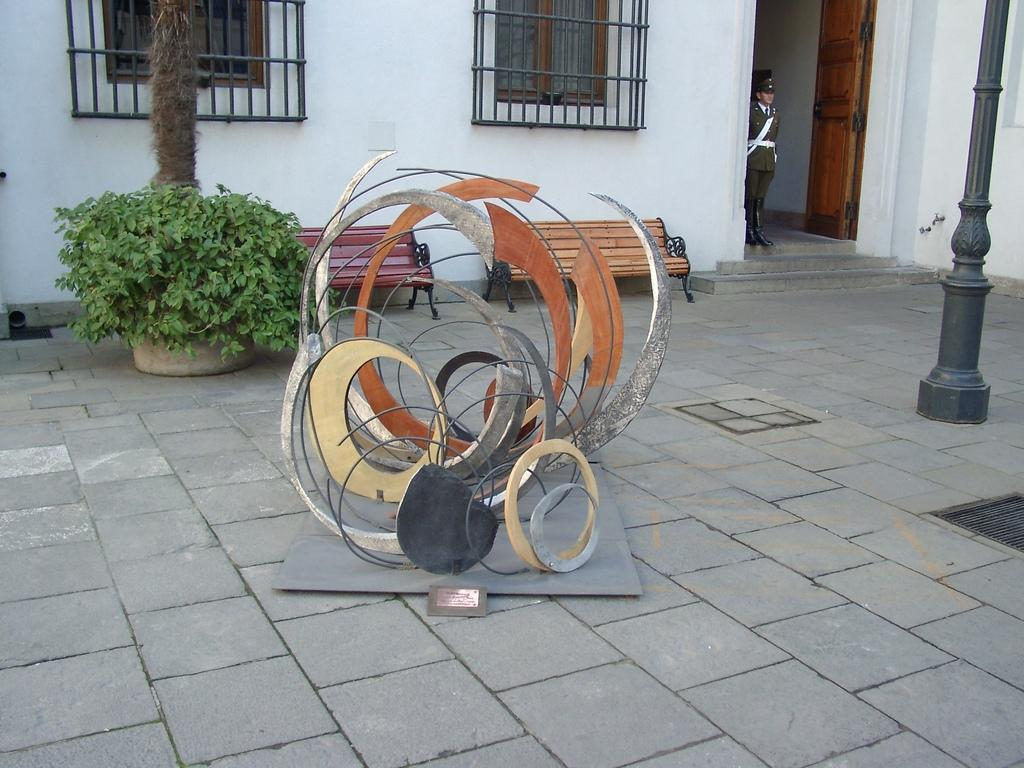What is the main object on the board in the image? The fact does not specify the type of object on the board, so we cannot answer this question definitively. What can be seen in the image besides the object on the board? There is a person standing, a pole, a plant, a building with windows and a door, benches, and iron grills in the image. Can you describe the person standing in the image? The fact does not provide any details about the person, so we cannot describe them. What is the purpose of the pole in the image? The fact does not specify the purpose of the pole, so we cannot answer this question definitively. How many windows and doors are on the building in the image? The fact states that there is a building with windows and a door in the image, but it does not specify the number of windows and doors. What type of plant is in the image? The fact does not specify the type of plant, so we cannot answer this question definitively. What are the benches used for in the image? The fact does not specify the purpose of the benches, so we cannot answer this question definitively. What is the purpose of the iron grills in the image? The fact does not specify the purpose of the iron grills, so we cannot answer this question definitively. Can you describe the tiger's fang in the image? There is no tiger or fang present in the image. 